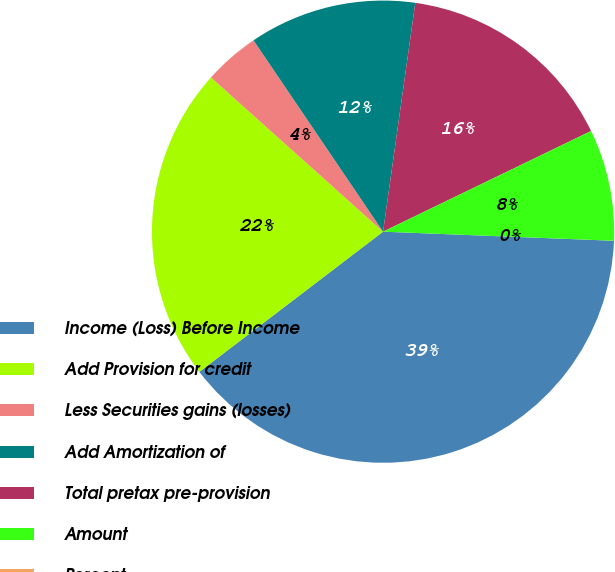Convert chart. <chart><loc_0><loc_0><loc_500><loc_500><pie_chart><fcel>Income (Loss) Before Income<fcel>Add Provision for credit<fcel>Less Securities gains (losses)<fcel>Add Amortization of<fcel>Total pretax pre-provision<fcel>Amount<fcel>Percent<nl><fcel>39.0%<fcel>22.0%<fcel>3.9%<fcel>11.7%<fcel>15.6%<fcel>7.8%<fcel>0.0%<nl></chart> 